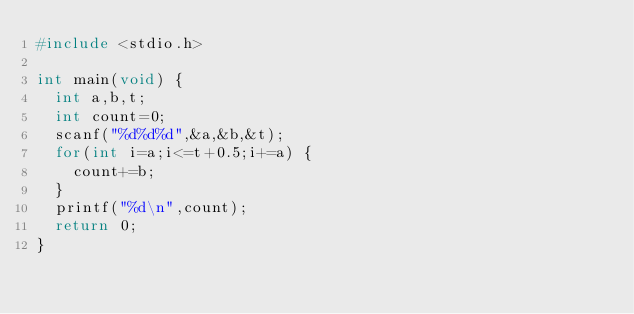<code> <loc_0><loc_0><loc_500><loc_500><_C_>#include <stdio.h>

int main(void) {
  int a,b,t;
  int count=0;
  scanf("%d%d%d",&a,&b,&t);
  for(int i=a;i<=t+0.5;i+=a) {
    count+=b;
  }
  printf("%d\n",count);
  return 0;
}</code> 